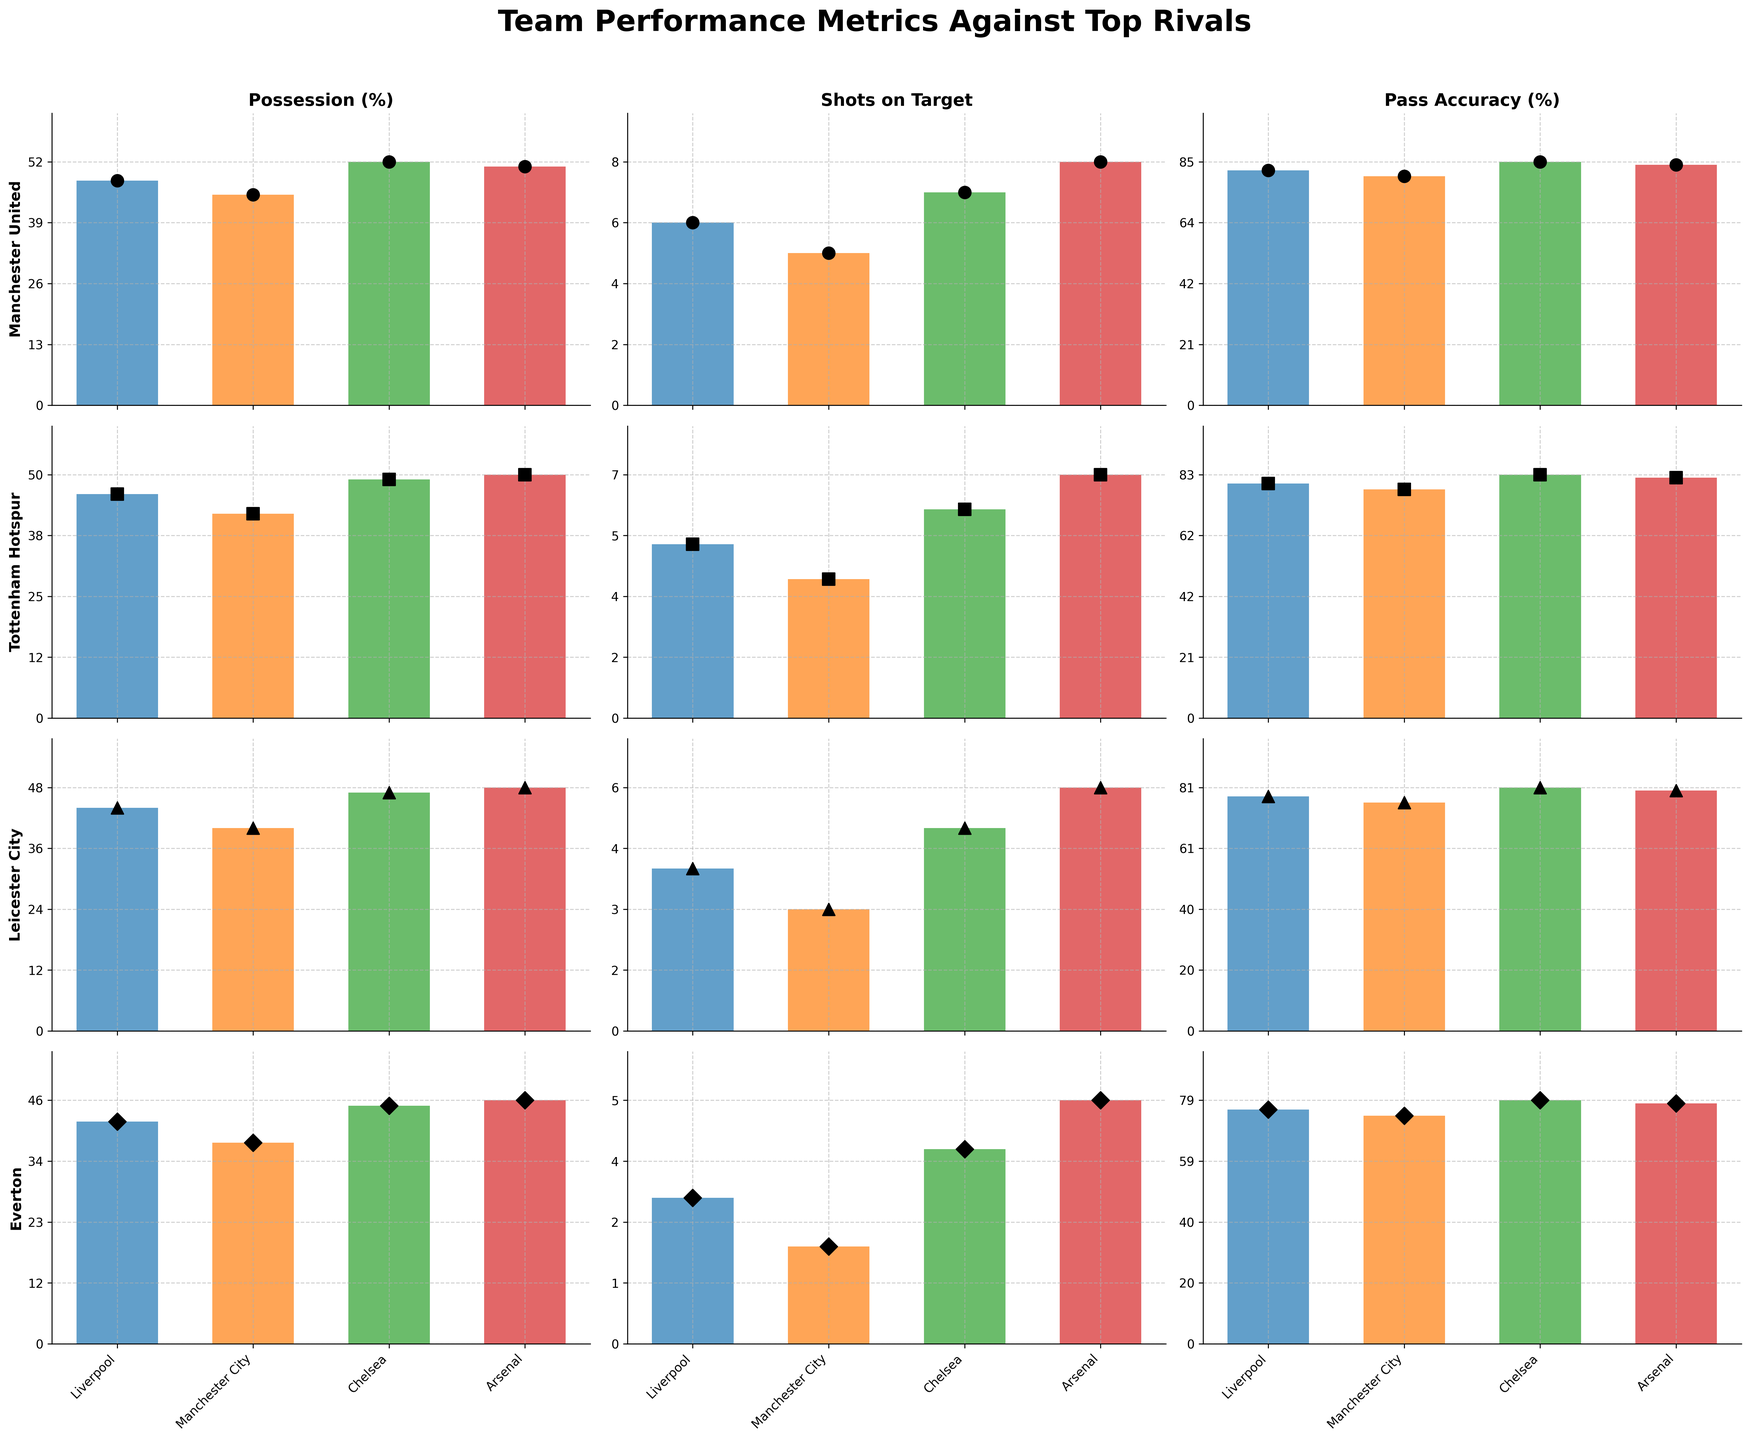Which team had the highest possession percentage against Chelsea? To find this, go to the column with the metric "Possession (%)" for Chelsea. Compare the bar heights for each team. The tallest bar corresponds to the highest percentage. The team with the highest possession percentage against Chelsea is Manchester United with 52%.
Answer: Manchester United What was the average pass accuracy for Leicester City against the rivals? Look at the pass accuracy values for Leicester City across all rivals: 78, 76, 81, and 80. Calculate the average: (78 + 76 + 81 + 80) / 4 = 315 / 4 = 78.75.
Answer: 78.75 Who had fewer shots on target against Liverpool, Tottenham Hotspur or Everton? Examine the data for shots on target against Liverpool. Tottenham Hotspur had 5 shots on target, and Everton had 3. Since 3 is less than 5, Everton had fewer shots on target.
Answer: Everton How did Tottenham Hotspur's possession percentage against Manchester City compare to Arsenal's against the same team? Look at the possession percentage for both Tottenham Hotspur and Arsenal against Manchester City. Tottenham Hotspur had 42%, and Arsenal had 45%. Since 42 is less than 45, Tottenham Hotspur had less possession than Arsenal.
Answer: Tottenham Hotspur had less What was Everton's average number of shots on target across all rivals? Look at Everton's shots on target values against all rivals: 3, 2, 4, and 5. Calculate the average: (3 + 2 + 4 + 5) / 4 = 14 / 4 = 3.5.
Answer: 3.5 Between Chelsea and Manchester City, which rival had a higher pass accuracy against Leicester City? Compare the pass accuracy values for Leicester City against Chelsea and Manchester City. Leicester City's pass accuracy against Chelsea is 81%, while against Manchester City it is 76%. 81% is higher than 76%, so Chelsea had a higher pass accuracy.
Answer: Chelsea 